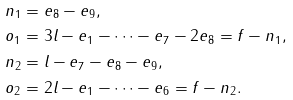<formula> <loc_0><loc_0><loc_500><loc_500>n _ { 1 } & = e _ { 8 } - e _ { 9 } , \\ o _ { 1 } & = 3 l - e _ { 1 } - \dots - e _ { 7 } - 2 e _ { 8 } = f - n _ { 1 } , \\ n _ { 2 } & = l - e _ { 7 } - e _ { 8 } - e _ { 9 } , \\ o _ { 2 } & = 2 l - e _ { 1 } - \dots - e _ { 6 } = f - n _ { 2 } .</formula> 